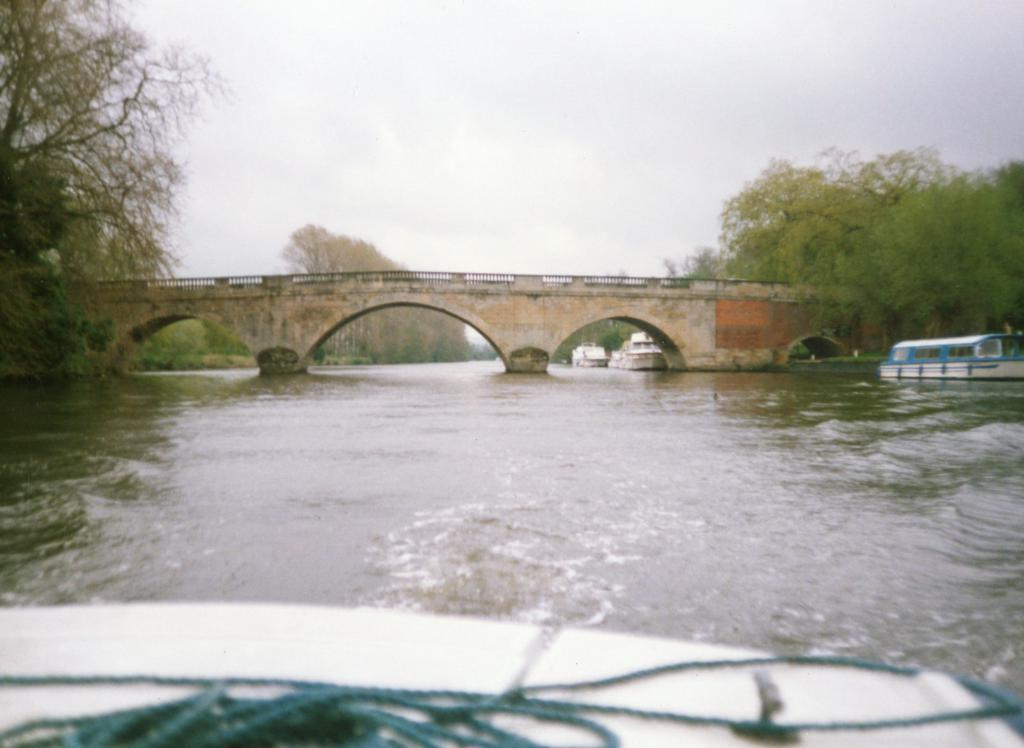What is the primary element in the image? There is water in the image. What is on the water in the image? There are boats on the water. What can be seen in the background of the image? There is a bridge and trees in the background of the image. How is the sky depicted in the image? The sky is clear in the background of the image. Where is the office located in the image? There is no office present in the image. What type of breakfast is being served on the boats in the image? There is no breakfast being served on the boats in the image; the boats are simply on the water. 